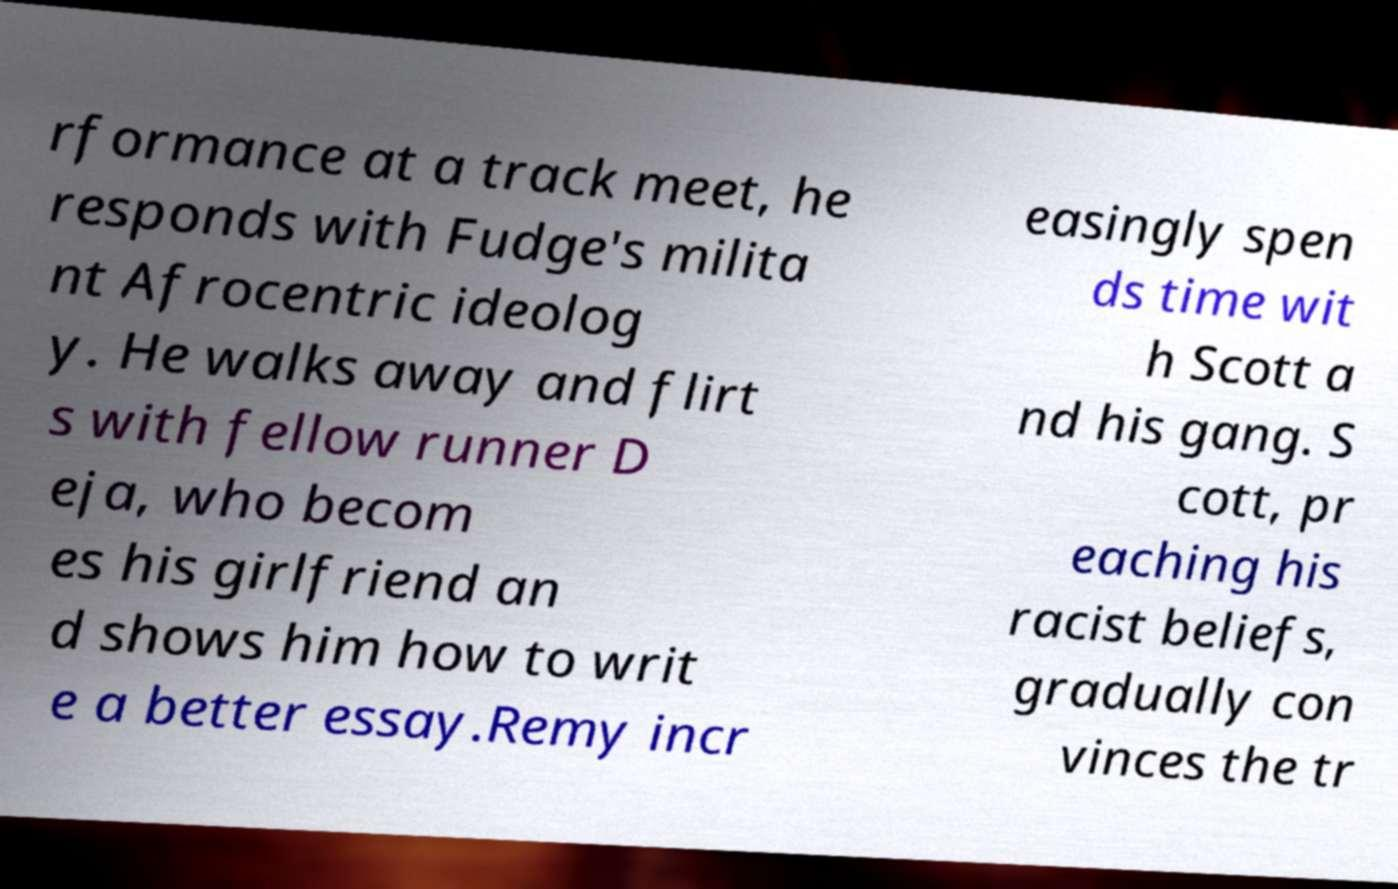Please identify and transcribe the text found in this image. rformance at a track meet, he responds with Fudge's milita nt Afrocentric ideolog y. He walks away and flirt s with fellow runner D eja, who becom es his girlfriend an d shows him how to writ e a better essay.Remy incr easingly spen ds time wit h Scott a nd his gang. S cott, pr eaching his racist beliefs, gradually con vinces the tr 